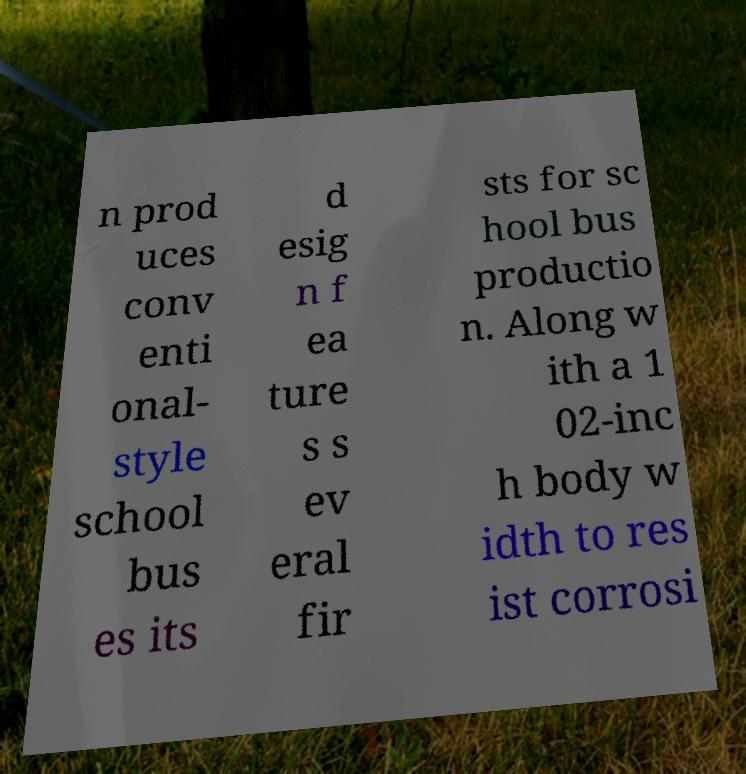What messages or text are displayed in this image? I need them in a readable, typed format. n prod uces conv enti onal- style school bus es its d esig n f ea ture s s ev eral fir sts for sc hool bus productio n. Along w ith a 1 02-inc h body w idth to res ist corrosi 